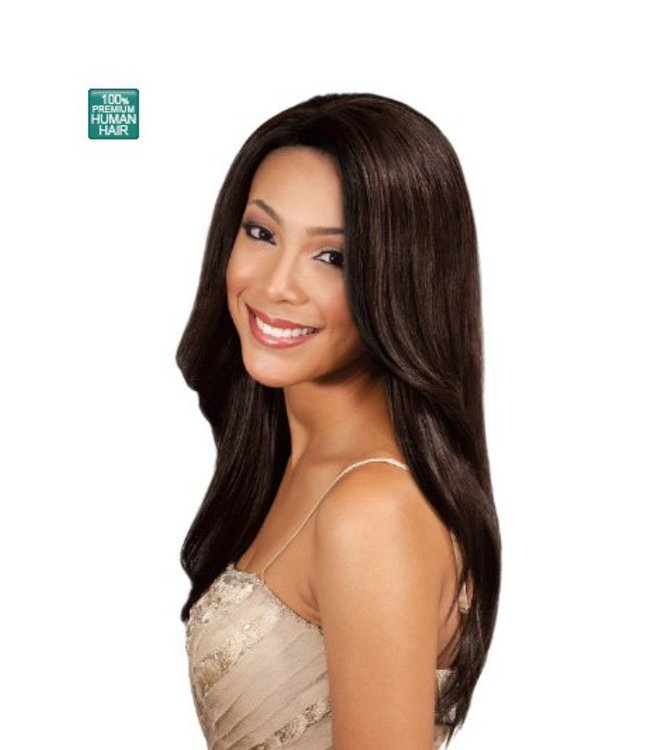Given the small green badge in the upper left corner with the text '100% HUMAN HAIR,' what might be the primary purpose of this image? The primary purpose of the image is likely to promote a hair product, such as a wig or hair extensions. The presence of the badge clearly stating '100% HUMAN HAIR' indicates that the product is made of real human hair, which often signifies higher quality and a more natural look and feel. The focus on the woman's hair emphasizes its smoothness, shine, and overall appearance, helping to attract potential customers by showcasing the benefits of choosing this product. 